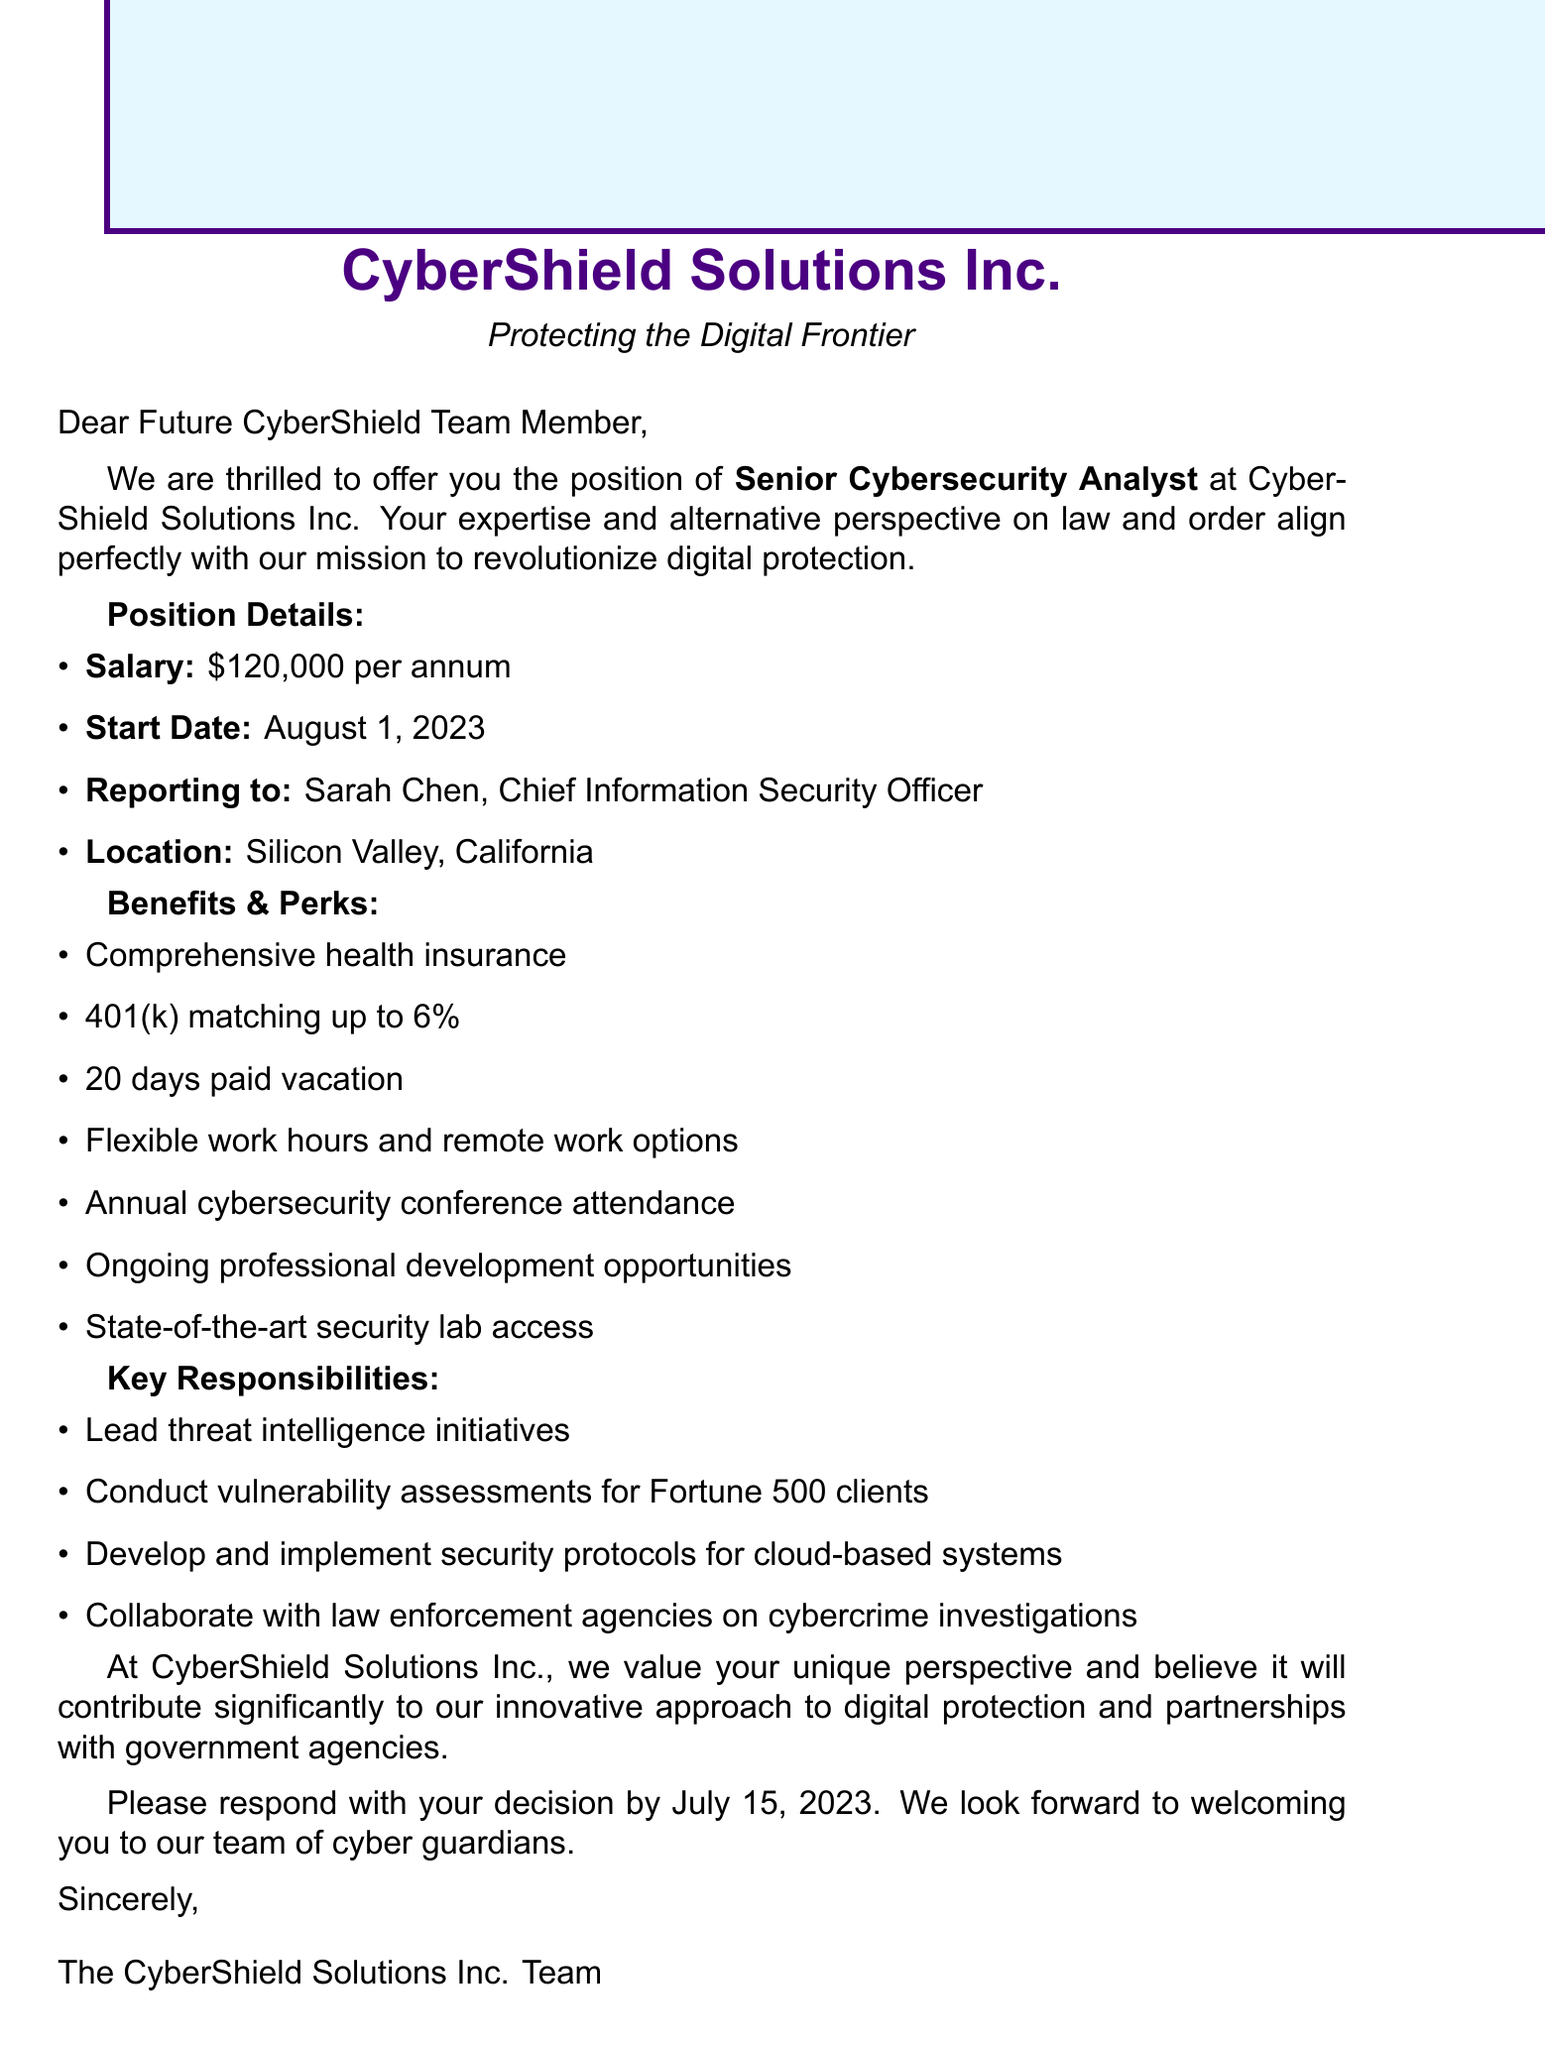What is the job title? The job title is explicitly mentioned in the document as the position offered, which is "Senior Cybersecurity Analyst."
Answer: Senior Cybersecurity Analyst What is the salary offered? The salary is stated in the document as "$120,000 per annum."
Answer: $120,000 per annum When is the start date? The start date is clearly specified in the document as "August 1, 2023."
Answer: August 1, 2023 Who will the new hire report to? The document identifies the person that the new employee will report to as "Sarah Chen, Chief Information Security Officer."
Answer: Sarah Chen, Chief Information Security Officer What are the remote work options? The document mentions one of the benefits as "Remote work options," indicating flexibility in work location.
Answer: Remote work options What is the deadline to respond to the job offer? The deadline for the response is clearly provided in the document as "July 15, 2023."
Answer: July 15, 2023 Which benefit includes financial planning? The benefit related to financial planning is described in the document as "401(k) matching up to 6%."
Answer: 401(k) matching up to 6% What type of projects will the new hire work on? The project responsibilities listed in the document include various tasks such as "Lead threat intelligence initiatives."
Answer: Lead threat intelligence initiatives Why is the company's approach to digital protection mentioned? The document highlights that the company's innovative approach is aligned with the new hire's unique perspective on law and order, indicating the importance of this perspective for the company's mission.
Answer: Innovative approach to digital protection 